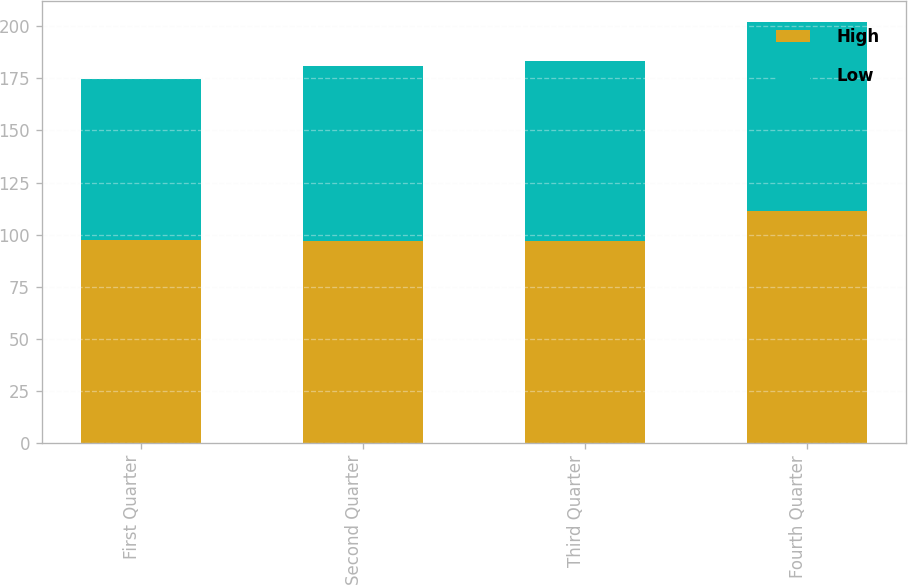Convert chart to OTSL. <chart><loc_0><loc_0><loc_500><loc_500><stacked_bar_chart><ecel><fcel>First Quarter<fcel>Second Quarter<fcel>Third Quarter<fcel>Fourth Quarter<nl><fcel>High<fcel>97.29<fcel>96.94<fcel>97.1<fcel>111.44<nl><fcel>Low<fcel>77.52<fcel>84.15<fcel>86.15<fcel>90.46<nl></chart> 